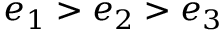Convert formula to latex. <formula><loc_0><loc_0><loc_500><loc_500>e _ { 1 } > e _ { 2 } > e _ { 3 }</formula> 